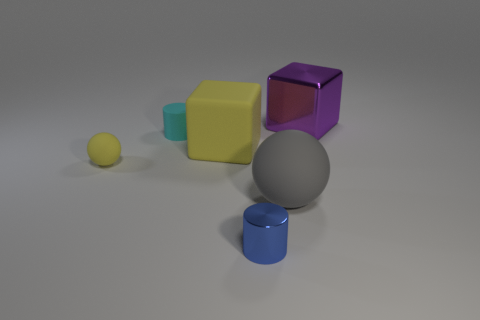Imagine these objects are part of a story, what could it be about? In the realm of imagination, these objects could belong to a mysterious puzzle room where each shape represents a clue to unlock a hidden secret. The varying colors and sizes might correspond to different keys or codes that need to be combined in a specific way to reveal a passage or treasure. 